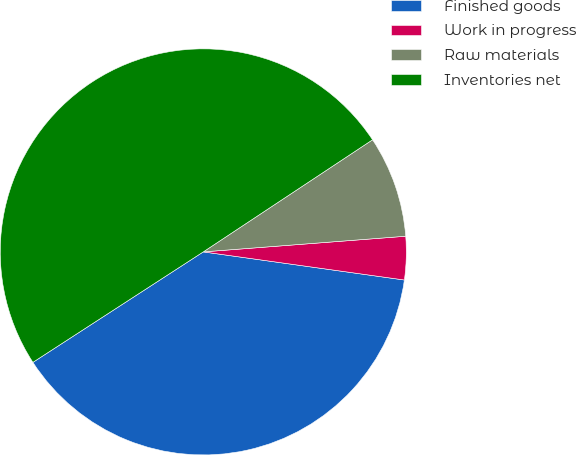Convert chart to OTSL. <chart><loc_0><loc_0><loc_500><loc_500><pie_chart><fcel>Finished goods<fcel>Work in progress<fcel>Raw materials<fcel>Inventories net<nl><fcel>38.63%<fcel>3.44%<fcel>8.08%<fcel>49.84%<nl></chart> 